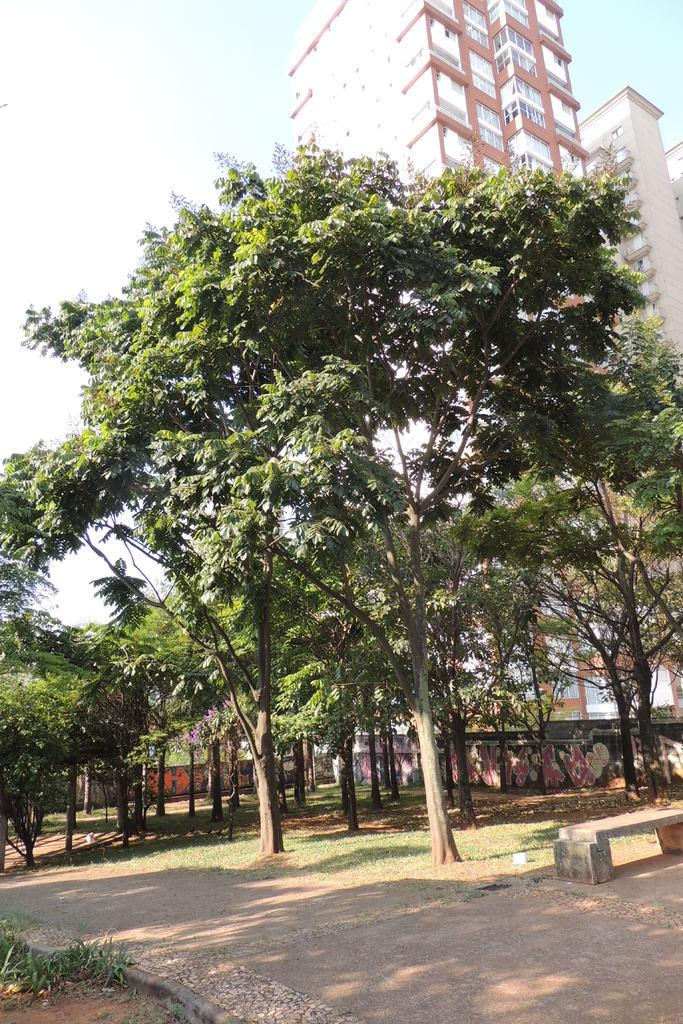What type of vegetation is present in the image? There are many trees in the image, as well as plants at the bottom of the image. What type of structures can be seen in the image? There are buildings and walls in the image. What architectural features are visible in the image? There are glass windows and a walkway at the bottom of the image. What type of seating is available at the bottom of the image? There is a bench at the bottom of the image. What type of ground cover is present at the bottom of the image? There is grass at the bottom of the image. What can be seen in the sky in the image? The sky is visible at the top of the image. What type of cord is used to hang the knee in the image? There is no knee or cord present in the image. How does the wash affect the appearance of the trees in the image? There is no mention of a wash in the image, and the appearance of the trees is not affected by any such element. 